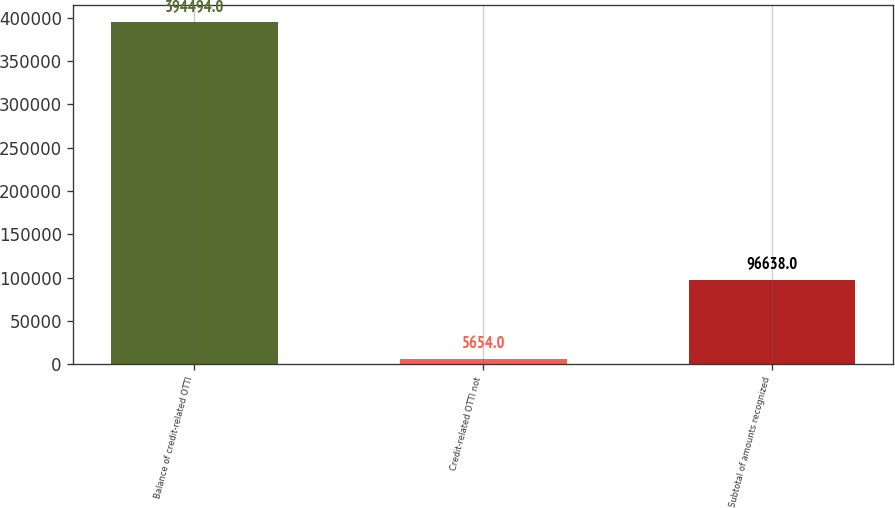Convert chart. <chart><loc_0><loc_0><loc_500><loc_500><bar_chart><fcel>Balance of credit-related OTTI<fcel>Credit-related OTTI not<fcel>Subtotal of amounts recognized<nl><fcel>394494<fcel>5654<fcel>96638<nl></chart> 